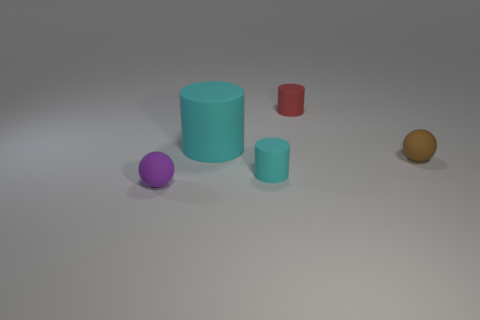Is the brown ball made of the same material as the cylinder in front of the big cyan rubber cylinder?
Offer a very short reply. Yes. The small matte thing that is both on the left side of the tiny red rubber thing and behind the purple matte object has what shape?
Your answer should be compact. Cylinder. How many other objects are there of the same color as the big cylinder?
Give a very brief answer. 1. What shape is the tiny purple matte object?
Give a very brief answer. Sphere. What color is the tiny rubber ball that is on the right side of the matte sphere to the left of the tiny cyan matte cylinder?
Offer a very short reply. Brown. There is a big cylinder; does it have the same color as the small cylinder that is on the left side of the red rubber thing?
Your answer should be very brief. Yes. What is the material of the tiny thing that is in front of the tiny brown rubber thing and behind the small purple thing?
Offer a terse response. Rubber. Are there any cyan cylinders that have the same size as the purple rubber ball?
Your response must be concise. Yes. There is a cyan cylinder that is the same size as the brown rubber ball; what is it made of?
Give a very brief answer. Rubber. There is a purple rubber object; how many tiny spheres are left of it?
Your response must be concise. 0. 